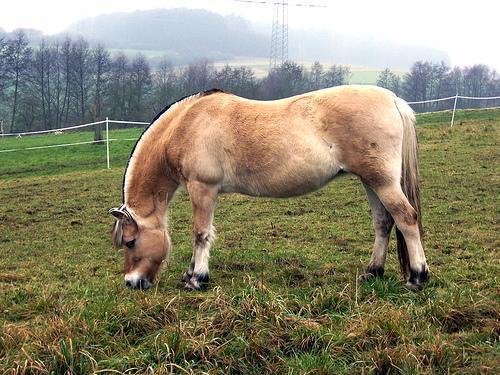How many horses are there?
Give a very brief answer. 1. 